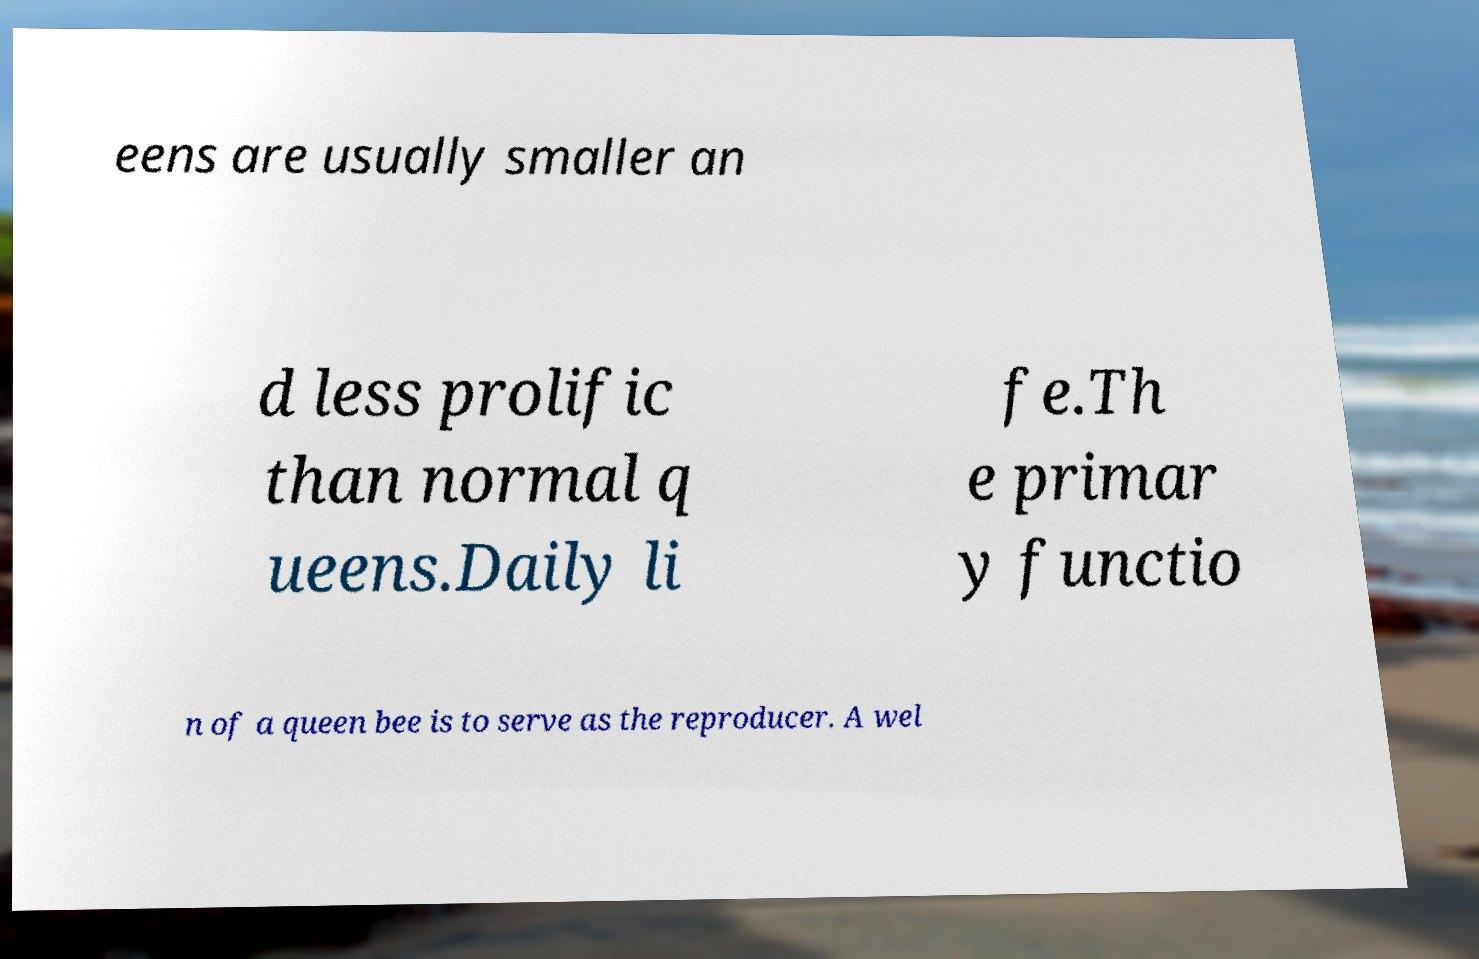I need the written content from this picture converted into text. Can you do that? eens are usually smaller an d less prolific than normal q ueens.Daily li fe.Th e primar y functio n of a queen bee is to serve as the reproducer. A wel 